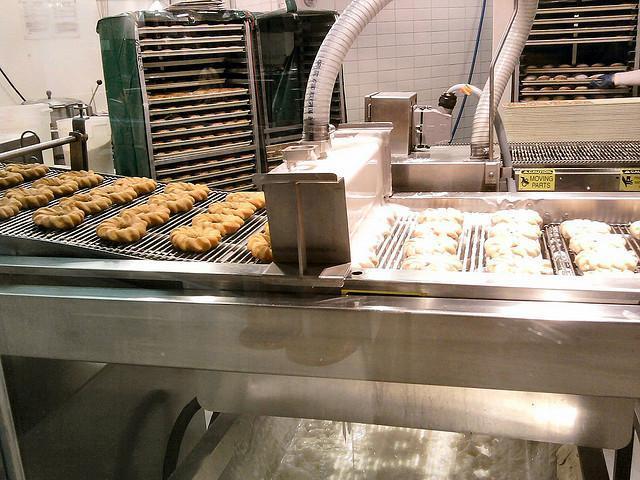How many donuts are there?
Give a very brief answer. 2. 